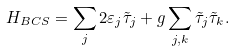<formula> <loc_0><loc_0><loc_500><loc_500>H _ { B C S } = \sum _ { j } 2 \varepsilon _ { j } \tilde { \tau } _ { j } + g \sum _ { j , k } \tilde { \tau } _ { j } \tilde { \tau } _ { k } .</formula> 